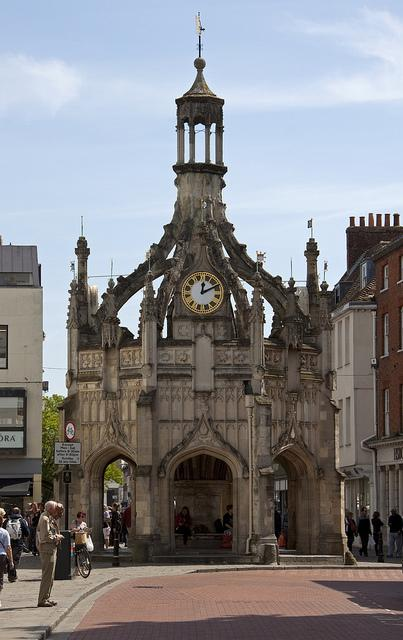Why would you look at this building?

Choices:
A) schedule
B) menu
C) time
D) temperature time 